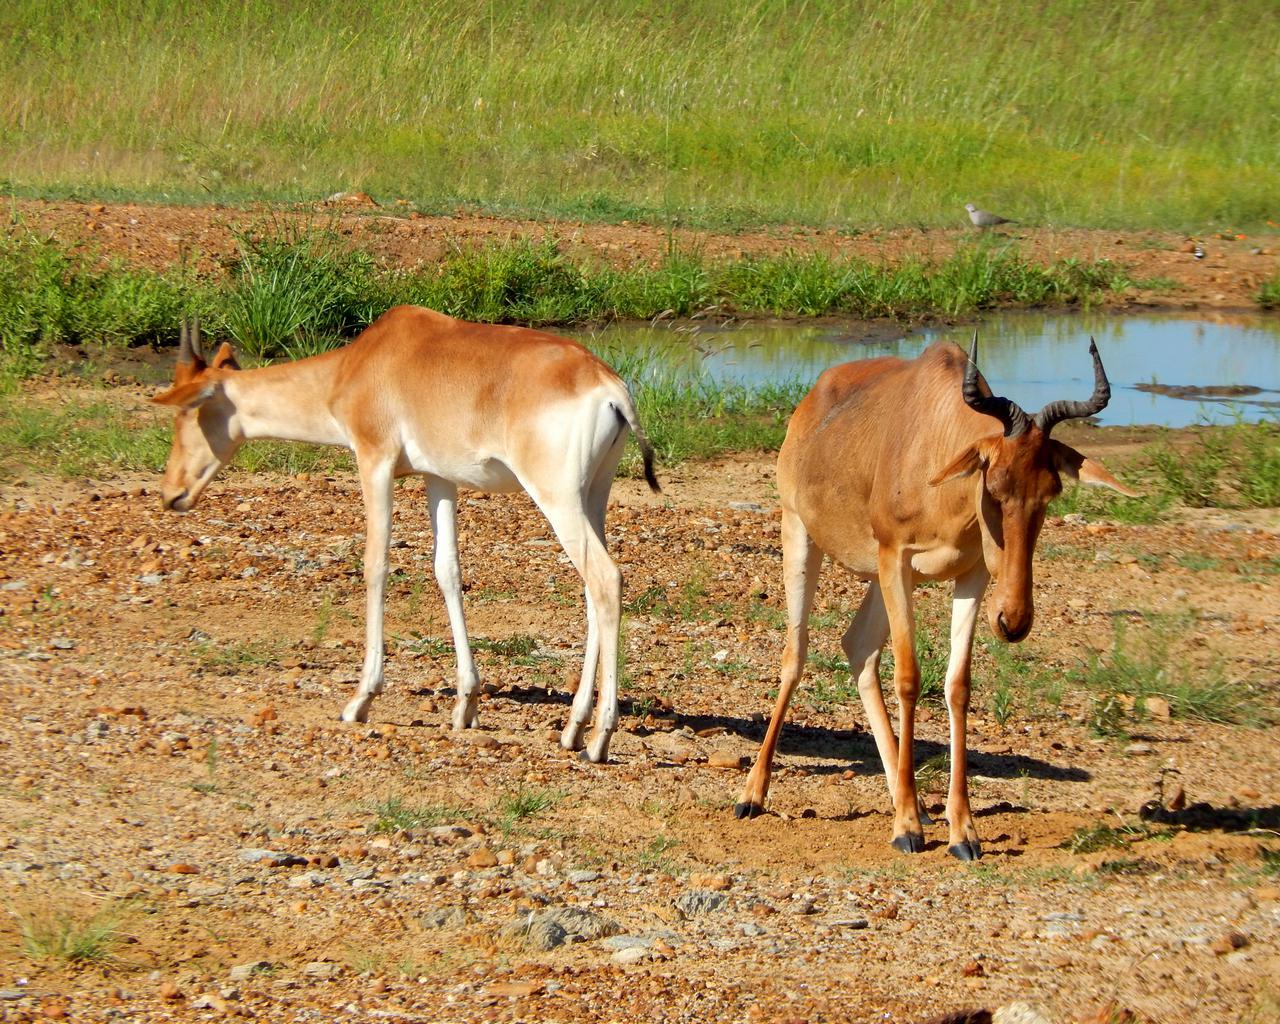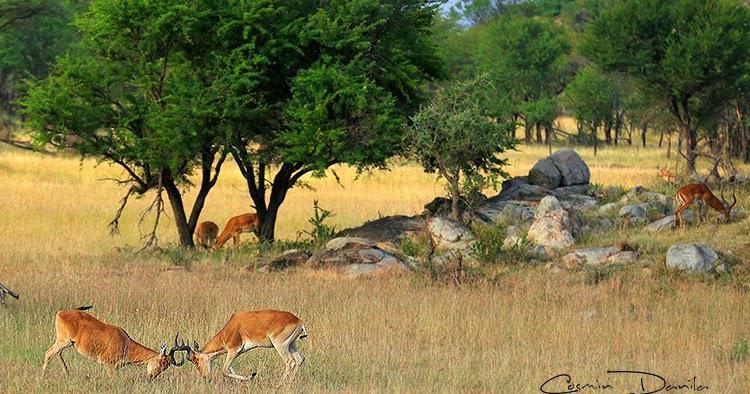The first image is the image on the left, the second image is the image on the right. Assess this claim about the two images: "An image shows just one horned animal, standing with its head in profile.". Correct or not? Answer yes or no. No. The first image is the image on the left, the second image is the image on the right. Examine the images to the left and right. Is the description "The two images contain a total of three animals." accurate? Answer yes or no. No. 